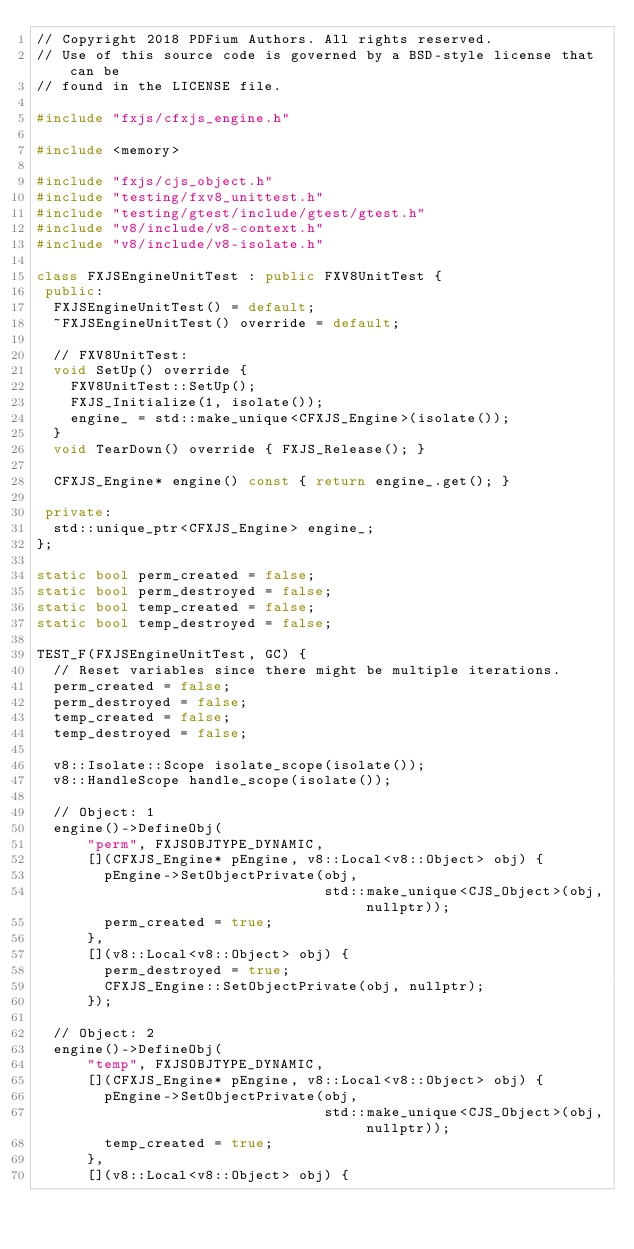<code> <loc_0><loc_0><loc_500><loc_500><_C++_>// Copyright 2018 PDFium Authors. All rights reserved.
// Use of this source code is governed by a BSD-style license that can be
// found in the LICENSE file.

#include "fxjs/cfxjs_engine.h"

#include <memory>

#include "fxjs/cjs_object.h"
#include "testing/fxv8_unittest.h"
#include "testing/gtest/include/gtest/gtest.h"
#include "v8/include/v8-context.h"
#include "v8/include/v8-isolate.h"

class FXJSEngineUnitTest : public FXV8UnitTest {
 public:
  FXJSEngineUnitTest() = default;
  ~FXJSEngineUnitTest() override = default;

  // FXV8UnitTest:
  void SetUp() override {
    FXV8UnitTest::SetUp();
    FXJS_Initialize(1, isolate());
    engine_ = std::make_unique<CFXJS_Engine>(isolate());
  }
  void TearDown() override { FXJS_Release(); }

  CFXJS_Engine* engine() const { return engine_.get(); }

 private:
  std::unique_ptr<CFXJS_Engine> engine_;
};

static bool perm_created = false;
static bool perm_destroyed = false;
static bool temp_created = false;
static bool temp_destroyed = false;

TEST_F(FXJSEngineUnitTest, GC) {
  // Reset variables since there might be multiple iterations.
  perm_created = false;
  perm_destroyed = false;
  temp_created = false;
  temp_destroyed = false;

  v8::Isolate::Scope isolate_scope(isolate());
  v8::HandleScope handle_scope(isolate());

  // Object: 1
  engine()->DefineObj(
      "perm", FXJSOBJTYPE_DYNAMIC,
      [](CFXJS_Engine* pEngine, v8::Local<v8::Object> obj) {
        pEngine->SetObjectPrivate(obj,
                                  std::make_unique<CJS_Object>(obj, nullptr));
        perm_created = true;
      },
      [](v8::Local<v8::Object> obj) {
        perm_destroyed = true;
        CFXJS_Engine::SetObjectPrivate(obj, nullptr);
      });

  // Object: 2
  engine()->DefineObj(
      "temp", FXJSOBJTYPE_DYNAMIC,
      [](CFXJS_Engine* pEngine, v8::Local<v8::Object> obj) {
        pEngine->SetObjectPrivate(obj,
                                  std::make_unique<CJS_Object>(obj, nullptr));
        temp_created = true;
      },
      [](v8::Local<v8::Object> obj) {</code> 